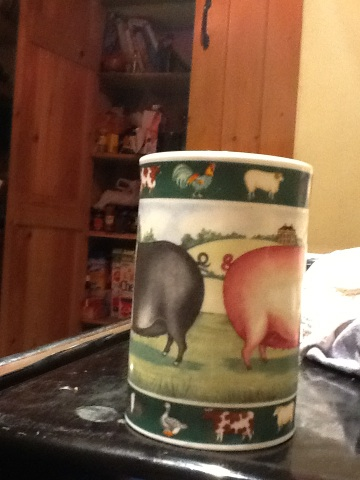How old do you think this cup might be? Based on the design and the wear visible in the image, the cup could be relatively new or a vintage piece designed to look rustic. Without specific marks or brand information, it’s difficult to determine its exact age. What is the historical significance of the art style on this cup? The art style on this cup features pastoral imagery commonly associated with traditional English or country-themed pottery. Such designs often evoke a sense of nostalgia and simplicity, reminiscent of bucolic farm life. This style can be traced back to the rustic themes popular in 18th and 19th century European ceramic art, which aimed to bring a touch of the countryside into everyday household items. 